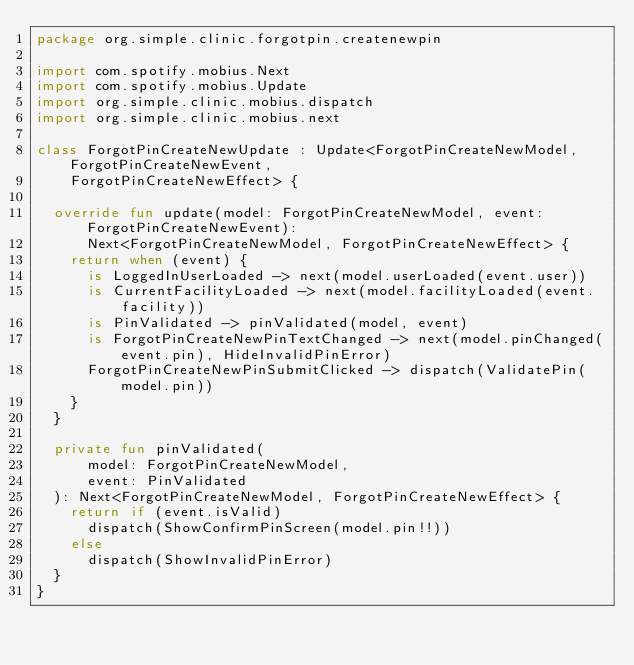Convert code to text. <code><loc_0><loc_0><loc_500><loc_500><_Kotlin_>package org.simple.clinic.forgotpin.createnewpin

import com.spotify.mobius.Next
import com.spotify.mobius.Update
import org.simple.clinic.mobius.dispatch
import org.simple.clinic.mobius.next

class ForgotPinCreateNewUpdate : Update<ForgotPinCreateNewModel, ForgotPinCreateNewEvent,
    ForgotPinCreateNewEffect> {

  override fun update(model: ForgotPinCreateNewModel, event: ForgotPinCreateNewEvent):
      Next<ForgotPinCreateNewModel, ForgotPinCreateNewEffect> {
    return when (event) {
      is LoggedInUserLoaded -> next(model.userLoaded(event.user))
      is CurrentFacilityLoaded -> next(model.facilityLoaded(event.facility))
      is PinValidated -> pinValidated(model, event)
      is ForgotPinCreateNewPinTextChanged -> next(model.pinChanged(event.pin), HideInvalidPinError)
      ForgotPinCreateNewPinSubmitClicked -> dispatch(ValidatePin(model.pin))
    }
  }

  private fun pinValidated(
      model: ForgotPinCreateNewModel,
      event: PinValidated
  ): Next<ForgotPinCreateNewModel, ForgotPinCreateNewEffect> {
    return if (event.isValid)
      dispatch(ShowConfirmPinScreen(model.pin!!))
    else
      dispatch(ShowInvalidPinError)
  }
}
</code> 